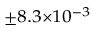<formula> <loc_0><loc_0><loc_500><loc_500>^ { \pm 8 . 3 \times 1 0 ^ { - 3 } }</formula> 